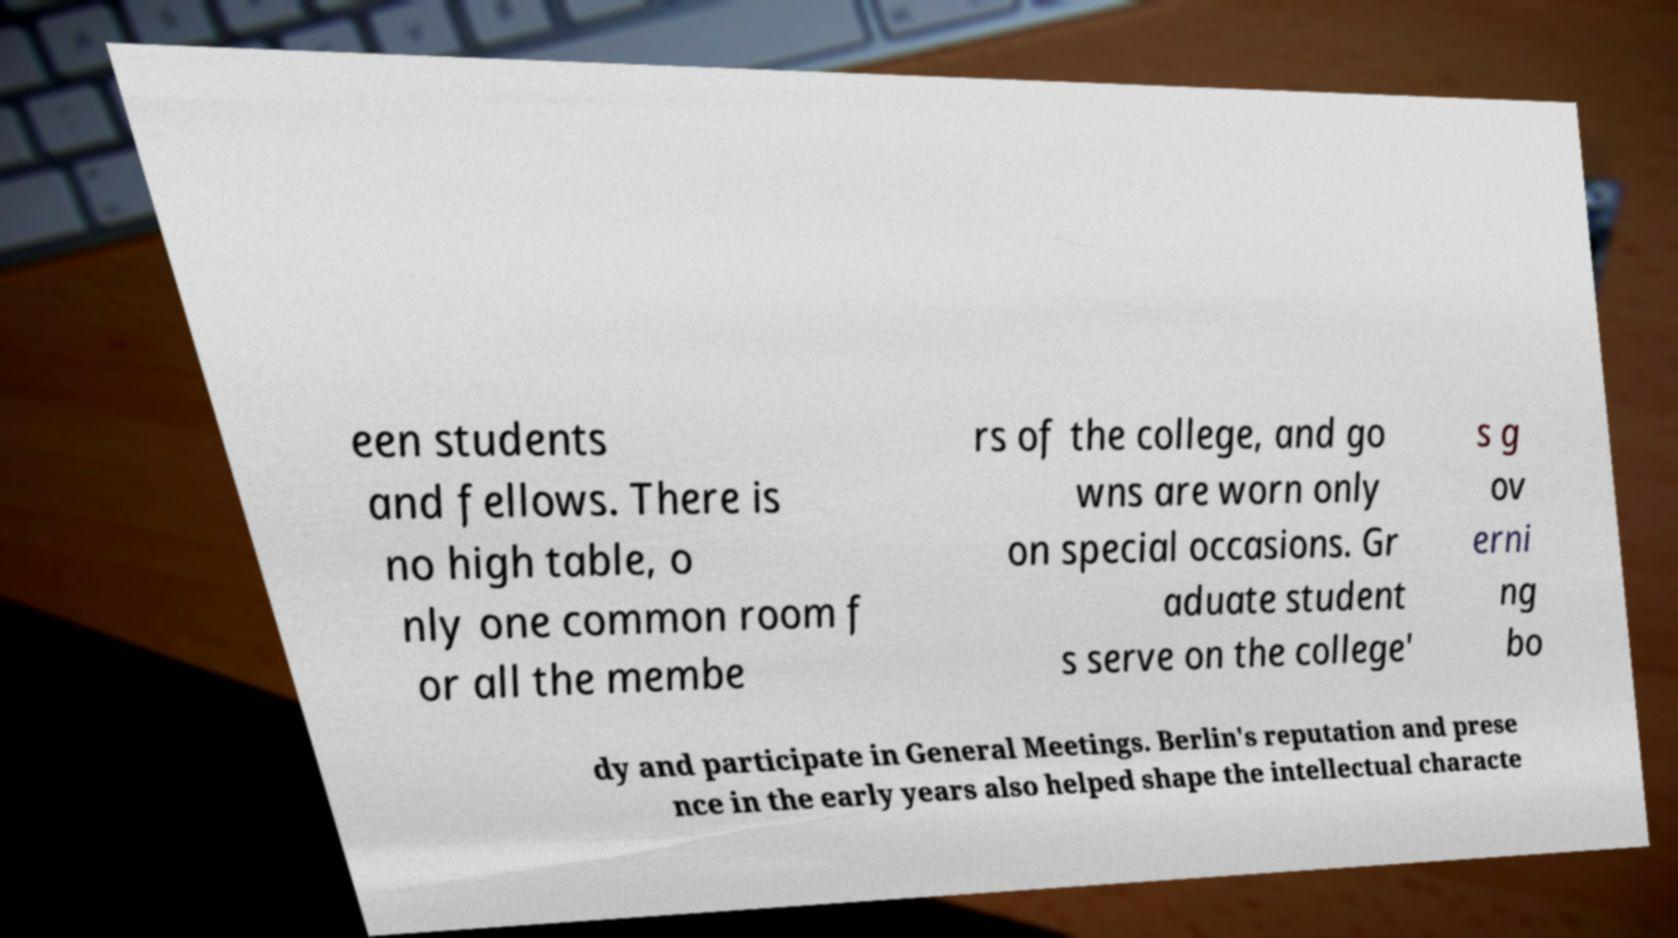Please identify and transcribe the text found in this image. een students and fellows. There is no high table, o nly one common room f or all the membe rs of the college, and go wns are worn only on special occasions. Gr aduate student s serve on the college' s g ov erni ng bo dy and participate in General Meetings. Berlin's reputation and prese nce in the early years also helped shape the intellectual characte 